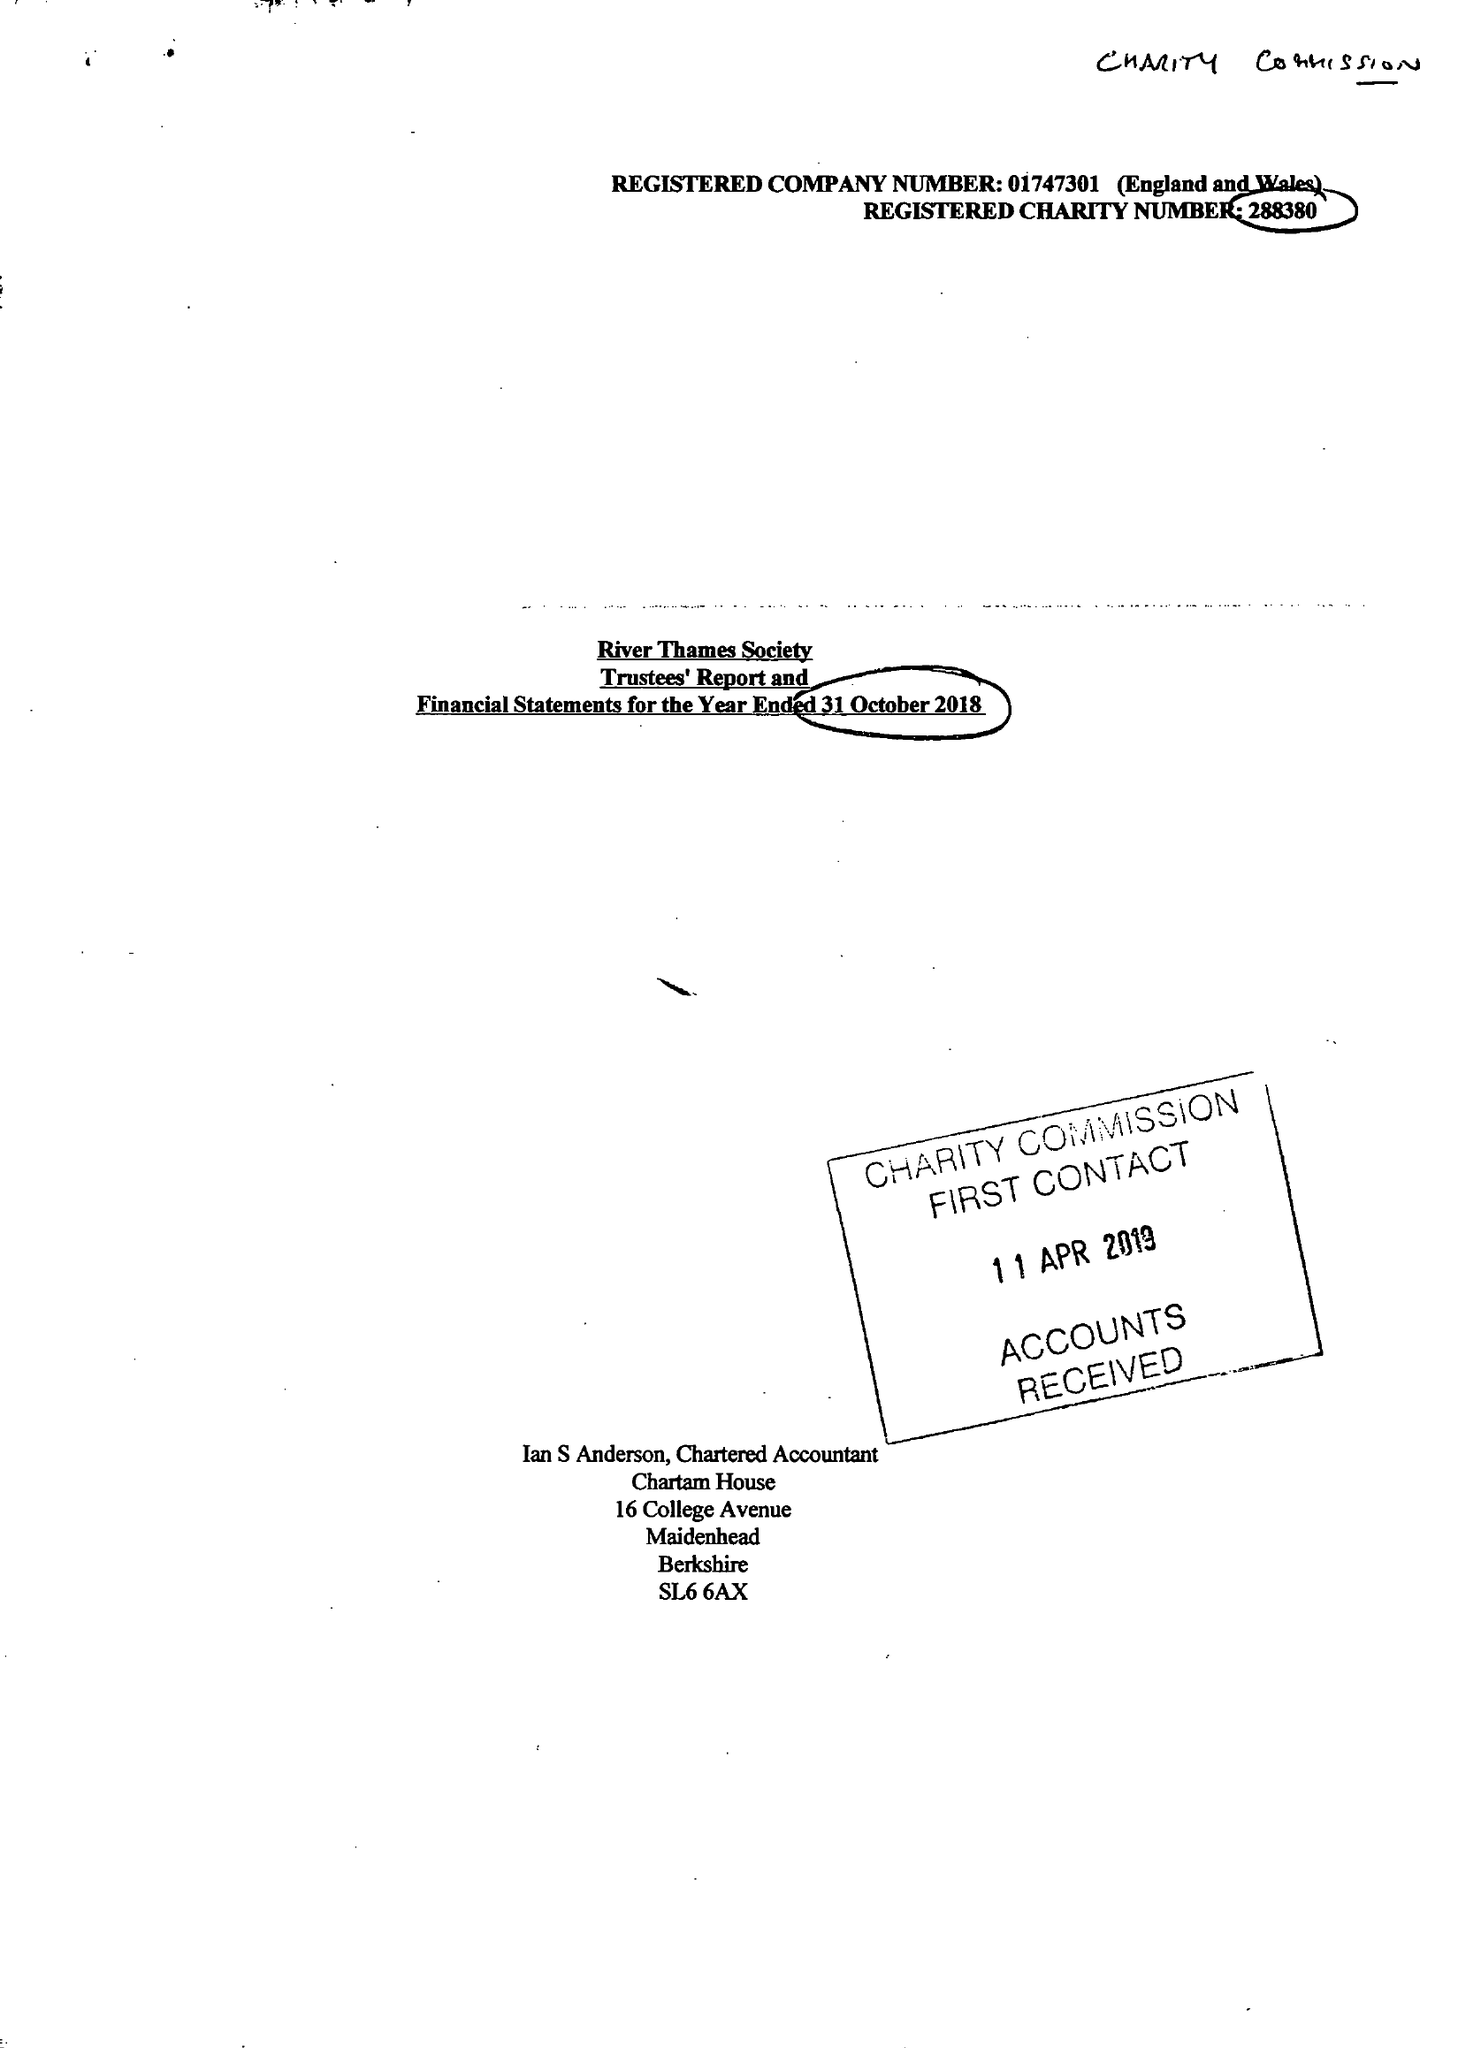What is the value for the income_annually_in_british_pounds?
Answer the question using a single word or phrase. 52154.00 